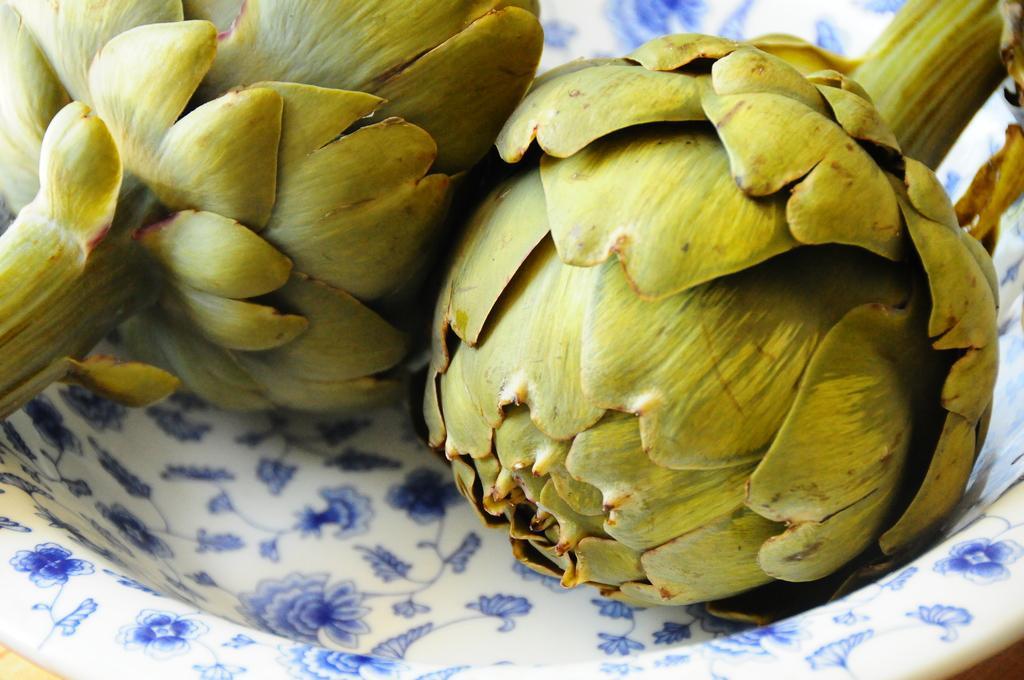Describe this image in one or two sentences. In this image, we can see plants in the bowl. 